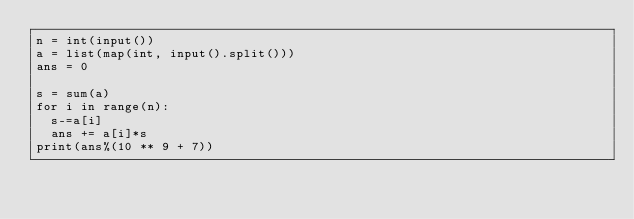<code> <loc_0><loc_0><loc_500><loc_500><_Python_>n = int(input())
a = list(map(int, input().split()))
ans = 0

s = sum(a)
for i in range(n):
  s-=a[i]
  ans += a[i]*s
print(ans%(10 ** 9 + 7))</code> 